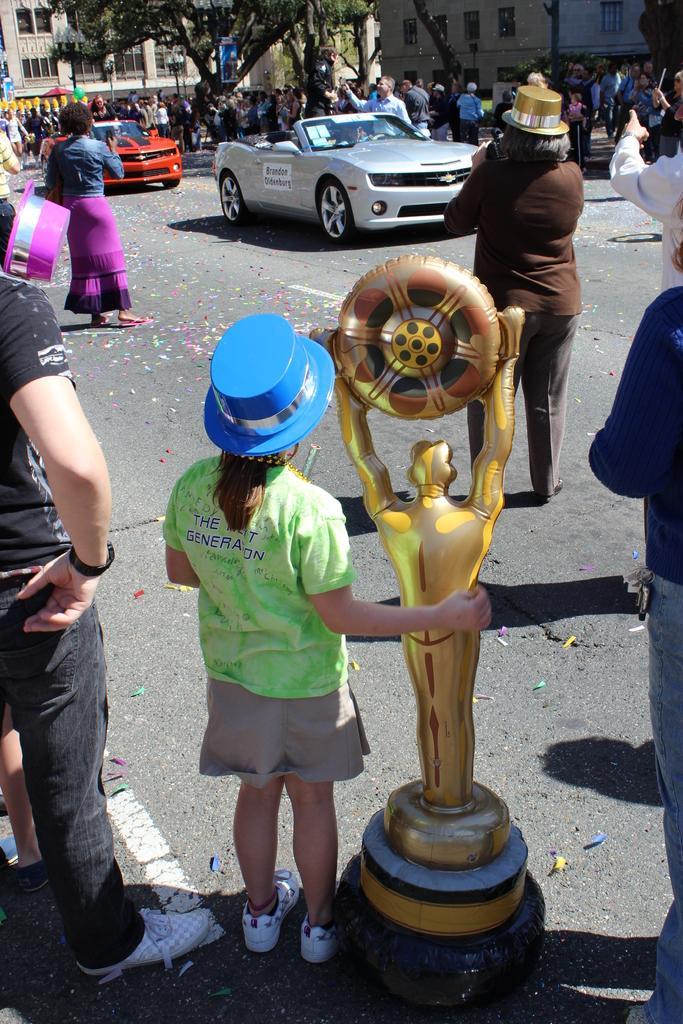Please provide a concise description of this image. Vehicles are on the road. This girl is holding a trophy. Beside this vehicle's there are peoples. Buildings with windows. In-front of this building there is a tree. 